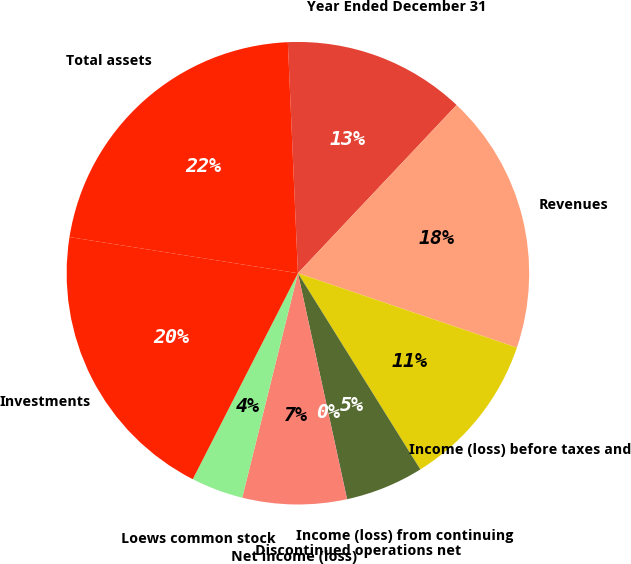Convert chart to OTSL. <chart><loc_0><loc_0><loc_500><loc_500><pie_chart><fcel>Year Ended December 31<fcel>Revenues<fcel>Income (loss) before taxes and<fcel>Income (loss) from continuing<fcel>Discontinued operations net<fcel>Net income (loss)<fcel>Loews common stock<fcel>Investments<fcel>Total assets<nl><fcel>12.73%<fcel>18.18%<fcel>10.91%<fcel>5.46%<fcel>0.01%<fcel>7.28%<fcel>3.64%<fcel>19.99%<fcel>21.81%<nl></chart> 